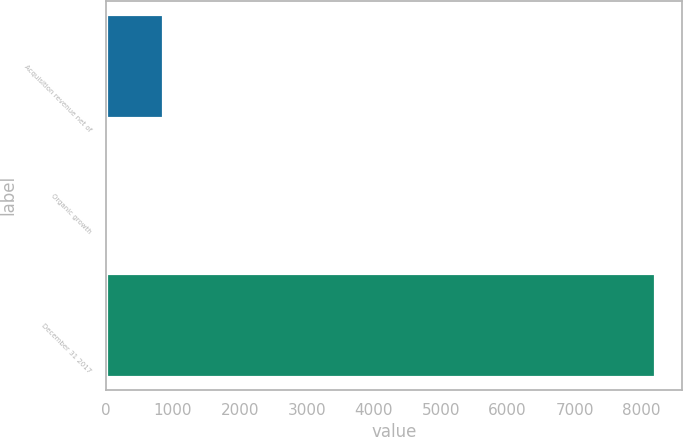Convert chart to OTSL. <chart><loc_0><loc_0><loc_500><loc_500><bar_chart><fcel>Acquisition revenue net of<fcel>Organic growth<fcel>December 31 2017<nl><fcel>858.84<fcel>43.5<fcel>8196.9<nl></chart> 